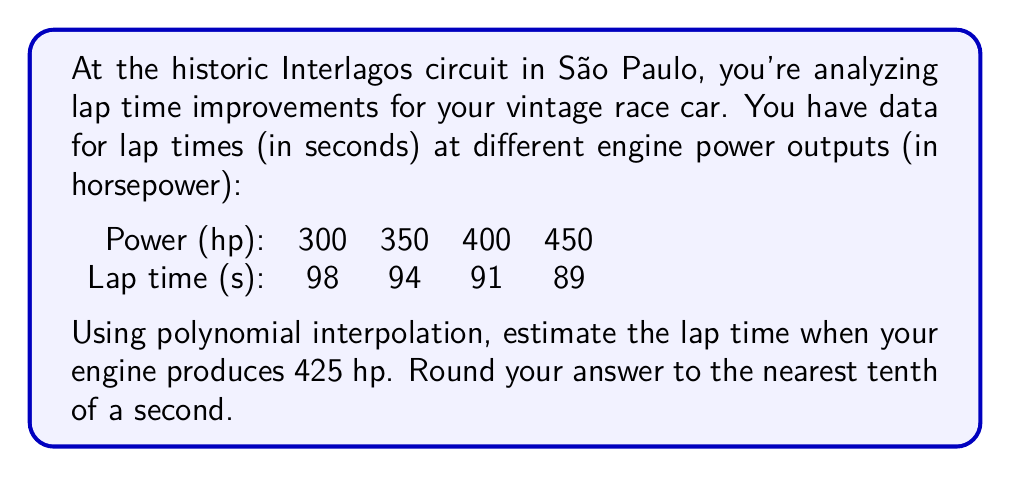What is the answer to this math problem? To solve this problem, we'll use Lagrange polynomial interpolation:

1) The Lagrange interpolation polynomial is given by:
   $$P(x) = \sum_{i=1}^n y_i \cdot L_i(x)$$
   where $L_i(x) = \prod_{j \neq i} \frac{x - x_j}{x_i - x_j}$

2) In our case:
   $x_1 = 300, x_2 = 350, x_3 = 400, x_4 = 450$
   $y_1 = 98, y_2 = 94, y_3 = 91, y_4 = 89$

3) We need to calculate $L_i(425)$ for $i = 1, 2, 3, 4$:

   $$L_1(425) = \frac{(425-350)(425-400)(425-450)}{(300-350)(300-400)(300-450)} = -0.0375$$
   $$L_2(425) = \frac{(425-300)(425-400)(425-450)}{(350-300)(350-400)(350-450)} = 0.3$$
   $$L_3(425) = \frac{(425-300)(425-350)(425-450)}{(400-300)(400-350)(400-450)} = 0.9$$
   $$L_4(425) = \frac{(425-300)(425-350)(425-400)}{(450-300)(450-350)(450-400)} = -0.1625$$

4) Now we can calculate $P(425)$:

   $$P(425) = 98 \cdot (-0.0375) + 94 \cdot 0.3 + 91 \cdot 0.9 + 89 \cdot (-0.1625)$$
   $$= -3.675 + 28.2 + 81.9 - 14.4625$$
   $$= 91.9625$$

5) Rounding to the nearest tenth: 91.9625 ≈ 92.0 seconds
Answer: 92.0 seconds 